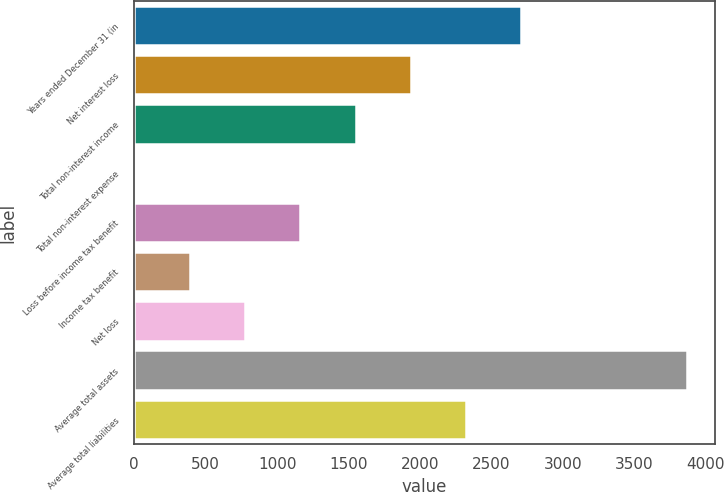<chart> <loc_0><loc_0><loc_500><loc_500><bar_chart><fcel>Years ended December 31 (in<fcel>Net interest loss<fcel>Total non-interest income<fcel>Total non-interest expense<fcel>Loss before income tax benefit<fcel>Income tax benefit<fcel>Net loss<fcel>Average total assets<fcel>Average total liabilities<nl><fcel>2709.6<fcel>1935.8<fcel>1548.9<fcel>1.3<fcel>1162<fcel>388.2<fcel>775.1<fcel>3870.3<fcel>2322.7<nl></chart> 